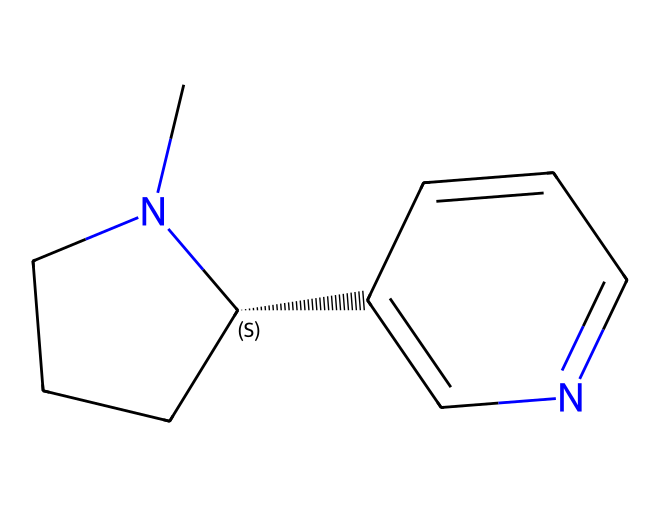how many nitrogen atoms are in this chemical structure? Observing the SMILES representation, we can identify two nitrogen atoms represented by the symbols 'N' in the structure.
Answer: 2 what is the molecular formula for nicotine? By analyzing the number of each type of atom in the structure using the SMILES, we find there are 10 carbon (C), 14 hydrogen (H), and 2 nitrogen (N) atoms, leading to the molecular formula C10H14N2.
Answer: C10H14N2 which type of bond is present between nitrogen and carbon? The structure of nicotine features single bonds between nitrogen and carbon atoms, which can be inferred by the lack of any double bond indicator in the SMILES for these atom pairs.
Answer: single bond what functional group is present in nicotine? In the nicotine structure, the pyridine ring features prominently, which is characteristic of the nitrogen-containing heterocycle; this indicates a nitrogen atom's presence within a cyclic structure, thus identifying a heterocyclic amine.
Answer: heterocyclic amine how does the presence of nitrogen contribute to the properties of nicotine? The nitrogen atom’s presence in the structure enhances basicity and neurotransmitter activity, characteristic of alkaloids, influencing its interaction with biological systems.
Answer: enhances basicity what ring system is present in nicotine? Analyzing the SMILES representation indicates that nicotine contains a bicyclic structure, consisting of a pyridine and a piperidine ring, contributing to its classification as an alkaloid.
Answer: bicyclic structure is nicotine a basic or acidic compound? Considering the structure and the nitrogen atoms, nicotine can accept protons due to the basic nature of its nitrogen atoms, thus confirming its classification as a basic compound.
Answer: basic 